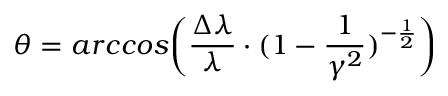<formula> <loc_0><loc_0><loc_500><loc_500>\theta = a r c \cos \left ( \frac { \Delta \lambda } { \lambda } \cdot ( 1 - \frac { 1 } { \gamma ^ { 2 } } ) ^ { - \frac { 1 } { 2 } } \right )</formula> 